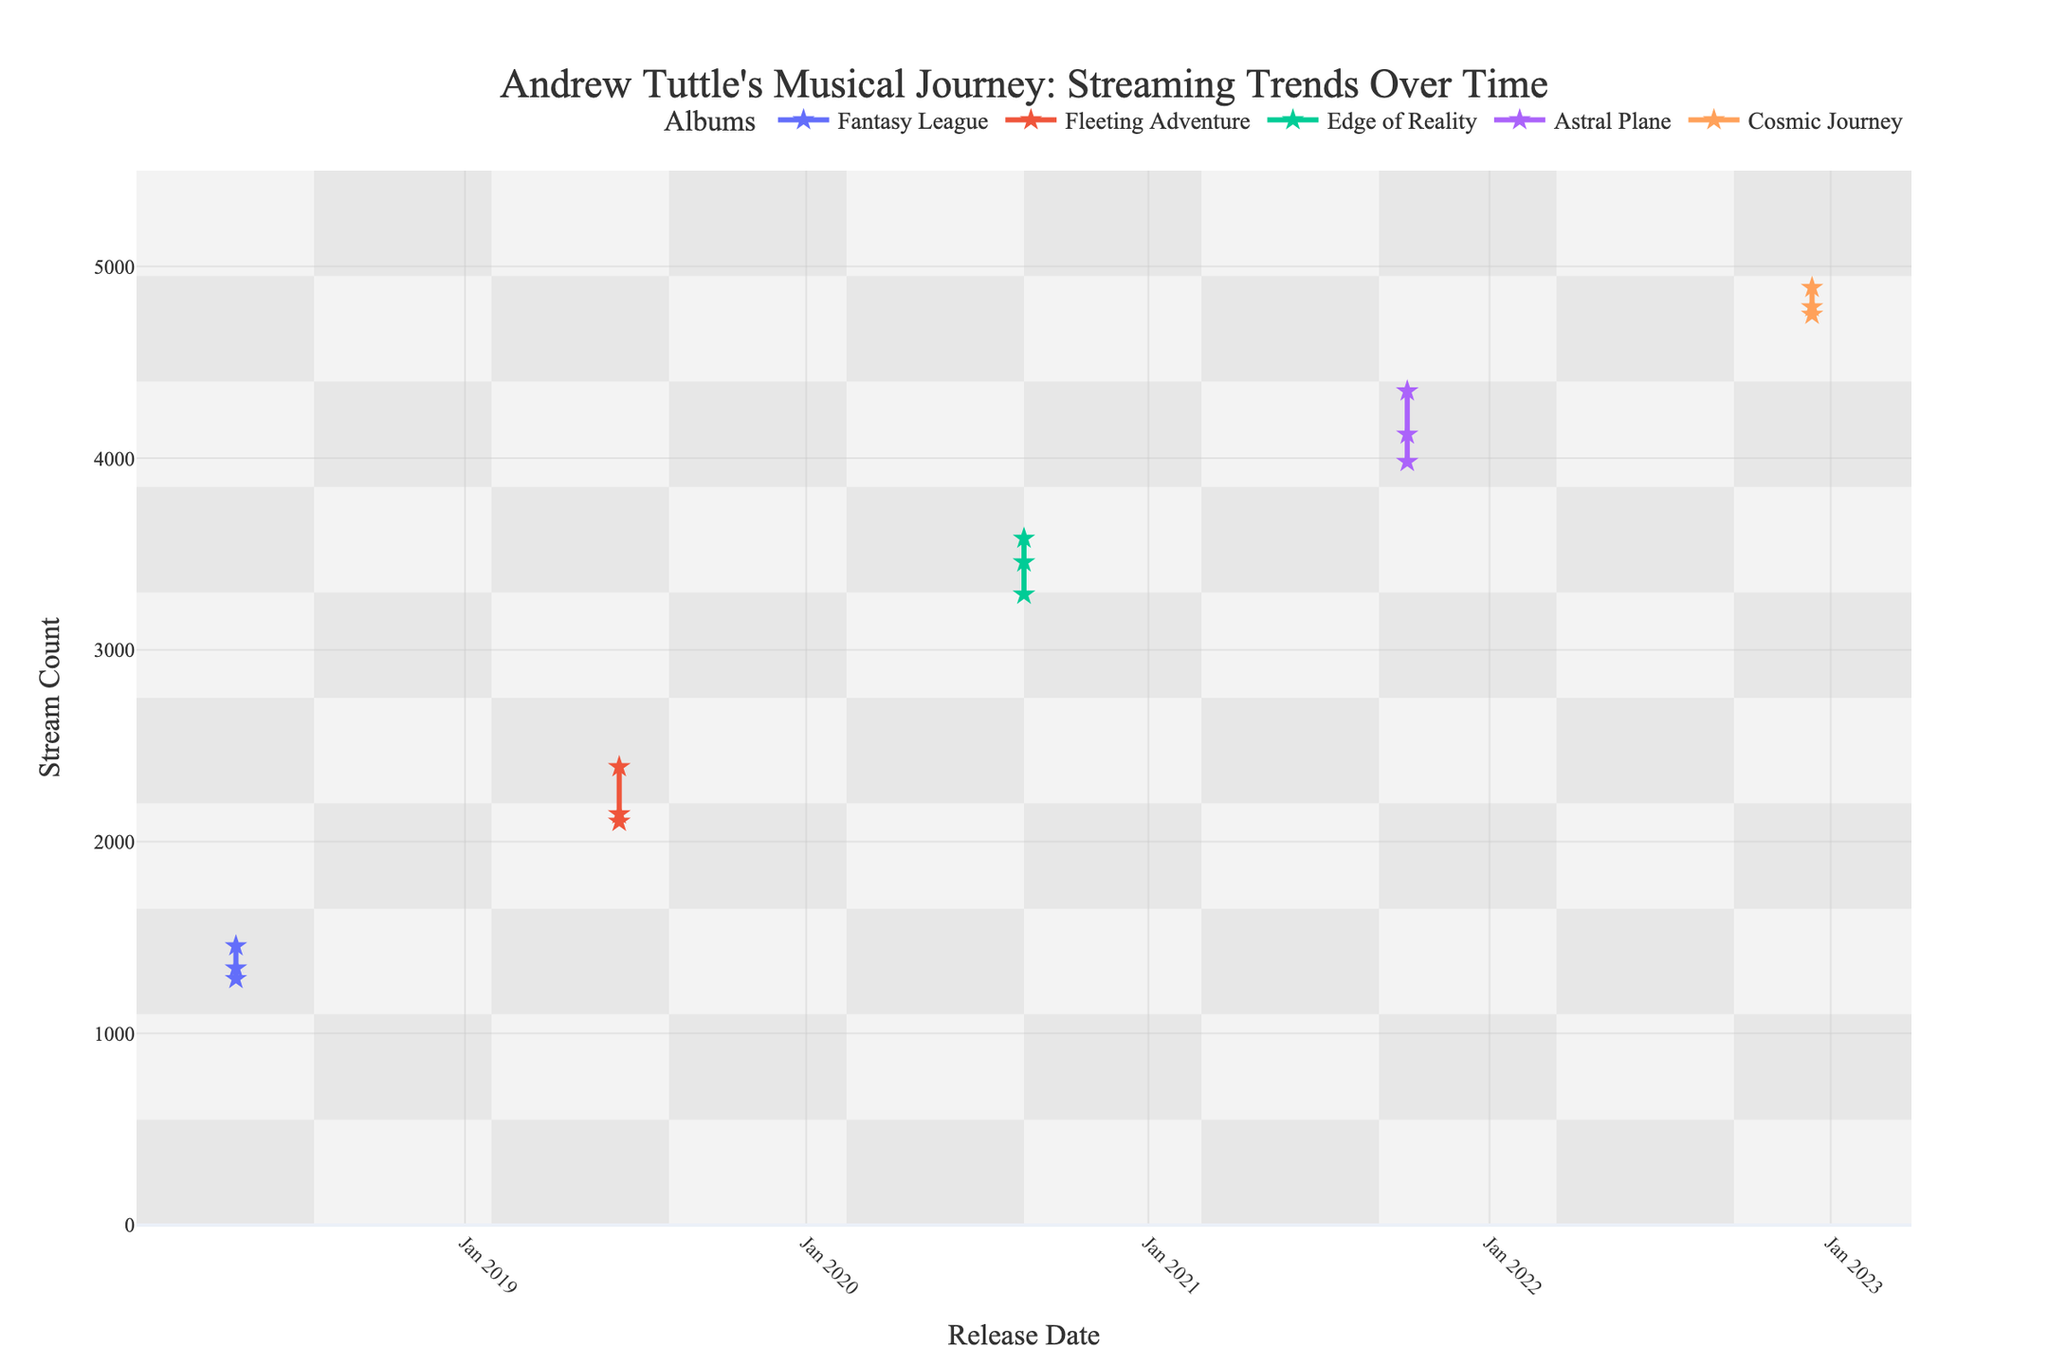What's the title of the plot? The title of the plot is usually displayed at the top of a figure. In this case, it refers to streaming trends over time for Andrew Tuttle's musical journey.
Answer: "Andrew Tuttle's Musical Journey: Streaming Trends Over Time" How many albums are represented in this plot? The plot legend shows the unique entries which represent each album. By counting these unique entries, we find the number of albums.
Answer: 5 Which album has the highest peak stream count, and what value is it? By analyzing the peaks for each album's trend line and looking at the y-axis for the maximum value, we can identify the album with the highest streaming figure.
Answer: "Cosmic Journey", 4890 What was the trend for the "Fantasy League" album from its release? Locate the date and corresponding stream counts for the tracks in the "Fantasy League" album. Note how the streams are relatively lower compared to later releases.
Answer: Relatively constant and lower compared to later albums On what date did Andrew Tuttle release the "Astral Plane" album? Look at the x-axis for the release markers and identify the date associated with "Astral Plane".
Answer: 2021-10-05 Which album saw a significant increase in stream counts compared to the previous ones? Compare the trend lines of subsequent albums, focusing on any major differences in streaming counts.
Answer: "Edge of Reality" How did the streams of "Cosmic Journey" tracks compare to those of "Edge of Reality" on their release dates? Observe the stream counts for the tracks from both albums on their respective release dates and compare their values.
Answer: Higher for "Cosmic Journey" What is the average stream count for the "Fleeting Adventure" album? Sum the stream counts of all tracks in the "Fleeting Adventure" album and divide by the number of tracks (3 in this case). (2390 + 2105 + 2144)/3 = 2213
Answer: 2213 Which album experienced the highest variability in stream counts among its tracks? Check the differences in stream counts for each track within an album and compare the variability among albums.
Answer: "Astral Plane" 